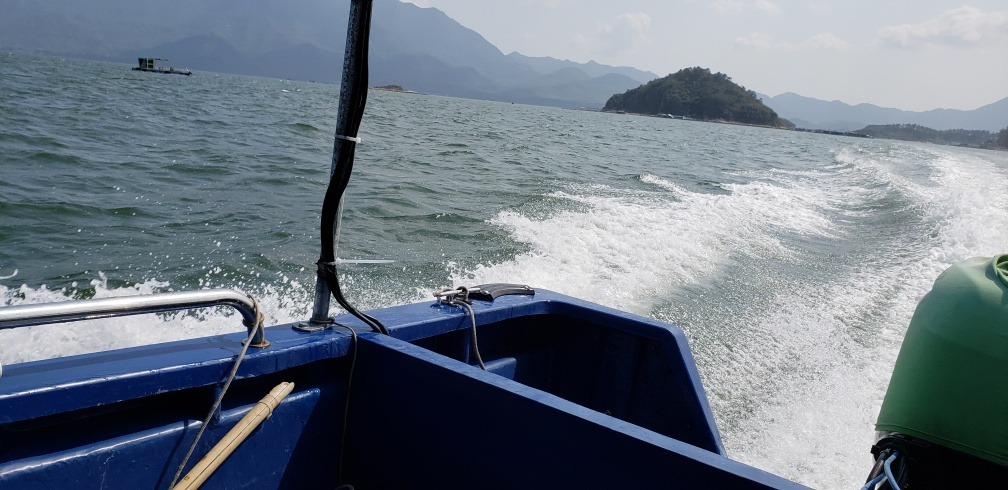Can you describe the setting of this image? The image captures a view from the deck of a boat, prominently featuring the boat's railing and the wake it has created on the water. In the distance, gentle mountain silhouettes can be seen under a hazy sky, suggesting a vast, open aquatic landscape possibly taken on a warm day. 